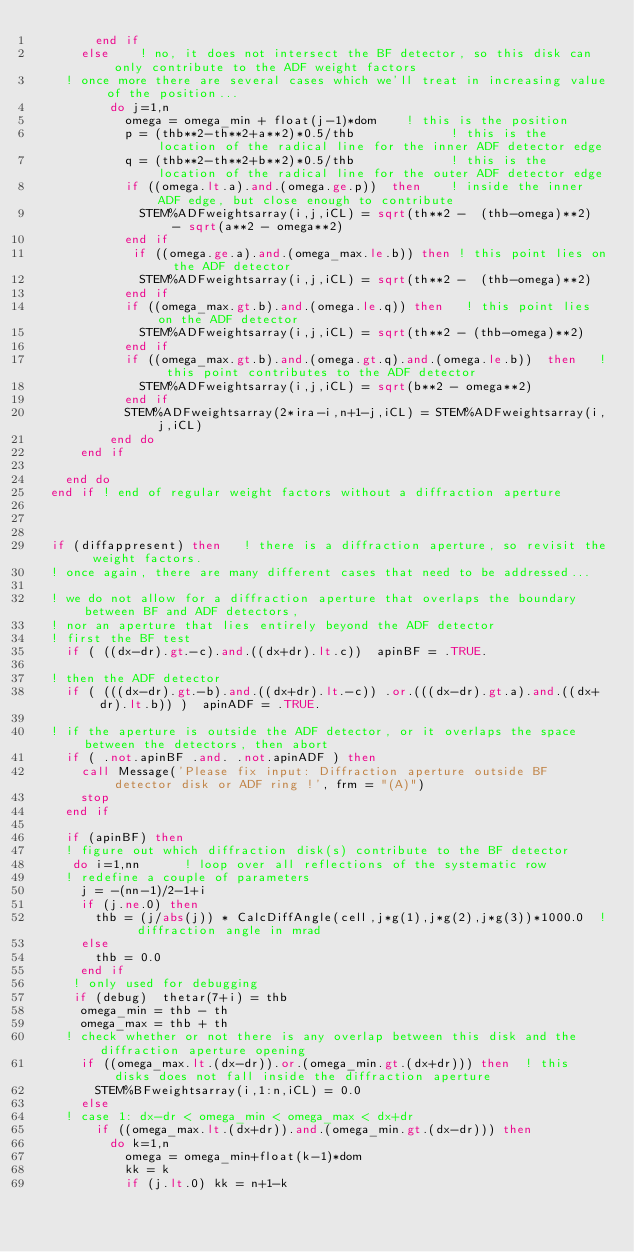Convert code to text. <code><loc_0><loc_0><loc_500><loc_500><_FORTRAN_>        end if 
      else    ! no, it does not intersect the BF detector, so this disk can only contribute to the ADF weight factors
    ! once more there are several cases which we'll treat in increasing value of the position...
          do j=1,n 
            omega = omega_min + float(j-1)*dom    ! this is the position
            p = (thb**2-th**2+a**2)*0.5/thb             ! this is the location of the radical line for the inner ADF detector edge
            q = (thb**2-th**2+b**2)*0.5/thb             ! this is the location of the radical line for the outer ADF detector edge
            if ((omega.lt.a).and.(omega.ge.p))  then    ! inside the inner ADF edge, but close enough to contribute
              STEM%ADFweightsarray(i,j,iCL) = sqrt(th**2 -  (thb-omega)**2)  - sqrt(a**2 - omega**2)
            end if
             if ((omega.ge.a).and.(omega_max.le.b)) then ! this point lies on the ADF detector 
              STEM%ADFweightsarray(i,j,iCL) = sqrt(th**2 -  (thb-omega)**2)
            end if
            if ((omega_max.gt.b).and.(omega.le.q)) then   ! this point lies on the ADF detector
              STEM%ADFweightsarray(i,j,iCL) = sqrt(th**2 - (thb-omega)**2)
            end if
            if ((omega_max.gt.b).and.(omega.gt.q).and.(omega.le.b))  then   ! this point contributes to the ADF detector
              STEM%ADFweightsarray(i,j,iCL) = sqrt(b**2 - omega**2)
            end if
            STEM%ADFweightsarray(2*ira-i,n+1-j,iCL) = STEM%ADFweightsarray(i,j,iCL)
          end do
      end if

    end do
  end if ! end of regular weight factors without a diffraction aperture



  if (diffappresent) then   ! there is a diffraction aperture, so revisit the weight factors.
  ! once again, there are many different cases that need to be addressed...
    
  ! we do not allow for a diffraction aperture that overlaps the boundary between BF and ADF detectors,
  ! nor an aperture that lies entirely beyond the ADF detector
  ! first the BF test
    if ( ((dx-dr).gt.-c).and.((dx+dr).lt.c))  apinBF = .TRUE.

  ! then the ADF detector
    if ( (((dx-dr).gt.-b).and.((dx+dr).lt.-c)) .or.(((dx-dr).gt.a).and.((dx+dr).lt.b)) )  apinADF = .TRUE. 

  ! if the aperture is outside the ADF detector, or it overlaps the space between the detectors, then abort
    if ( .not.apinBF .and. .not.apinADF ) then
      call Message('Please fix input: Diffraction aperture outside BF detector disk or ADF ring !', frm = "(A)")
      stop
    end if

    if (apinBF) then
    ! figure out which diffraction disk(s) contribute to the BF detector
     do i=1,nn      ! loop over all reflections of the systematic row
    ! redefine a couple of parameters
      j = -(nn-1)/2-1+i
      if (j.ne.0) then 
        thb = (j/abs(j)) * CalcDiffAngle(cell,j*g(1),j*g(2),j*g(3))*1000.0  ! diffraction angle in mrad
      else
        thb = 0.0
      end if  
     ! only used for debugging
     if (debug)  thetar(7+i) = thb
      omega_min = thb - th
      omega_max = thb + th
    ! check whether or not there is any overlap between this disk and the diffraction aperture opening
      if ((omega_max.lt.(dx-dr)).or.(omega_min.gt.(dx+dr))) then  ! this disks does not fall inside the diffraction aperture 
        STEM%BFweightsarray(i,1:n,iCL) = 0.0
      else
    ! case 1: dx-dr < omega_min < omega_max < dx+dr
        if ((omega_max.lt.(dx+dr)).and.(omega_min.gt.(dx-dr))) then
          do k=1,n
            omega = omega_min+float(k-1)*dom
            kk = k
            if (j.lt.0) kk = n+1-k </code> 